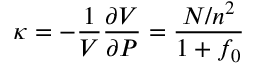<formula> <loc_0><loc_0><loc_500><loc_500>\kappa = - { \frac { 1 } { V } } { \frac { \partial V } { \partial P } } = { \frac { N / n ^ { 2 } } { 1 + f _ { 0 } } }</formula> 